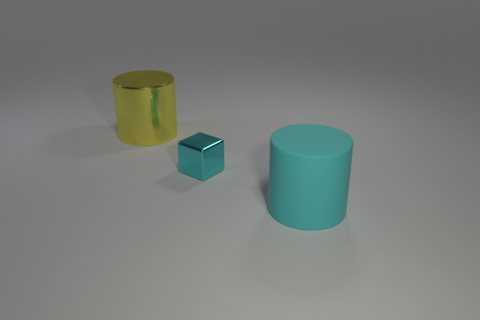Subtract all yellow cylinders. How many cylinders are left? 1 Add 2 cyan rubber things. How many objects exist? 5 Subtract all purple cubes. Subtract all cyan cylinders. How many cubes are left? 1 Subtract all yellow spheres. How many cyan cylinders are left? 1 Subtract all small green metallic cylinders. Subtract all big yellow shiny things. How many objects are left? 2 Add 1 big metal things. How many big metal things are left? 2 Add 3 small cyan cubes. How many small cyan cubes exist? 4 Subtract 0 brown cubes. How many objects are left? 3 Subtract all cubes. How many objects are left? 2 Subtract 1 cylinders. How many cylinders are left? 1 